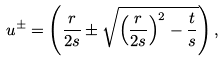Convert formula to latex. <formula><loc_0><loc_0><loc_500><loc_500>u ^ { \pm } = \left ( \frac { r } { 2 s } \pm \sqrt { \left ( \frac { r } { 2 s } \right ) ^ { 2 } - \frac { t } { s } } \right ) ,</formula> 